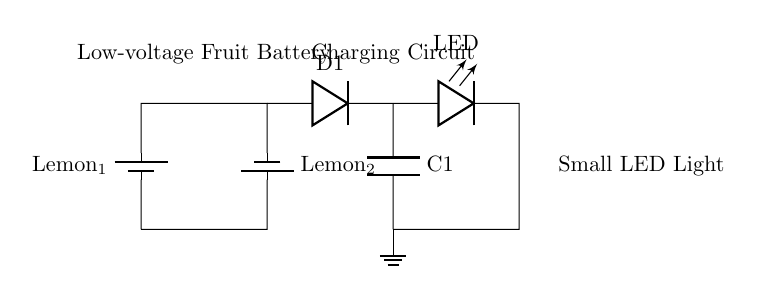What are the two types of batteries used in this circuit? The circuit contains two batteries labeled "Lemon_1" and "Lemon_2", which are both lemon fruit batteries that generate low voltage.
Answer: Lemon_1, Lemon_2 What component is used to allow current to flow in one direction? The diode labeled "D1" is used to allow current to flow in one direction, preventing any backflow which could damage the other components.
Answer: D1 What is the total voltage produced by the two lemon batteries in series? Each lemon battery typically produces around 0.7 to 1 volt, so in series, the total voltage would be approximately 1.4 to 2 volts depending on the exact voltage of the individual batteries.
Answer: 1.4 to 2 volts Which component stores electrical energy in the circuit? The capacitor labeled "C1" is the component responsible for storing electrical energy in the circuit, which can be released when needed.
Answer: C1 What type of light is being powered in this circuit? The circuit is designed to power a light-emitting diode, commonly known as an LED, which lights up when current passes through it.
Answer: LED What is the purpose of the ground connection in this circuit? The ground connection provides a common return path for electric current, ensuring the circuit is complete and stabilizing the voltage level in the circuit.
Answer: Ground 